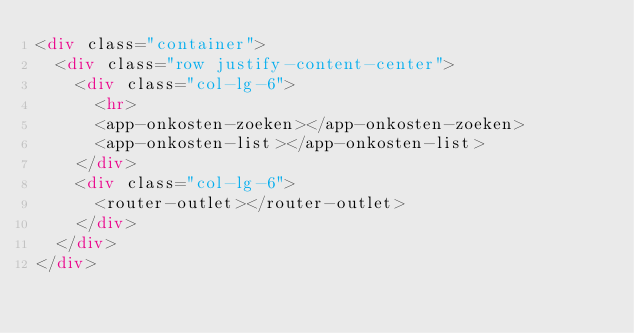<code> <loc_0><loc_0><loc_500><loc_500><_HTML_><div class="container">
  <div class="row justify-content-center">
    <div class="col-lg-6">
      <hr>
      <app-onkosten-zoeken></app-onkosten-zoeken>
      <app-onkosten-list></app-onkosten-list>
    </div>
    <div class="col-lg-6">
      <router-outlet></router-outlet>
    </div>
  </div>
</div>

</code> 